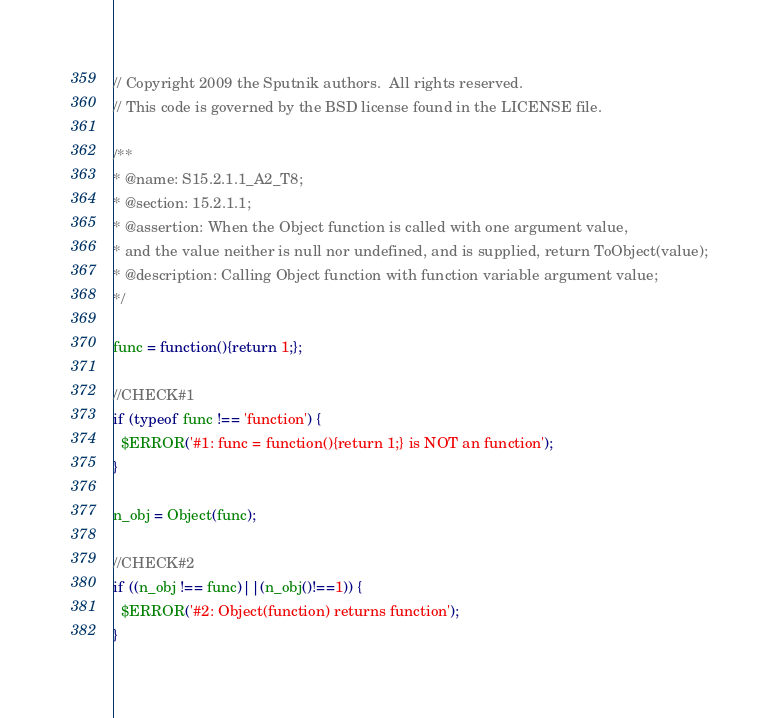Convert code to text. <code><loc_0><loc_0><loc_500><loc_500><_JavaScript_>// Copyright 2009 the Sputnik authors.  All rights reserved.
// This code is governed by the BSD license found in the LICENSE file.

/**
* @name: S15.2.1.1_A2_T8;
* @section: 15.2.1.1;
* @assertion: When the Object function is called with one argument value,
* and the value neither is null nor undefined, and is supplied, return ToObject(value);
* @description: Calling Object function with function variable argument value;
*/

func = function(){return 1;};

//CHECK#1
if (typeof func !== 'function') {
  $ERROR('#1: func = function(){return 1;} is NOT an function');
}

n_obj = Object(func);

//CHECK#2
if ((n_obj !== func)||(n_obj()!==1)) {
  $ERROR('#2: Object(function) returns function');
}

</code> 